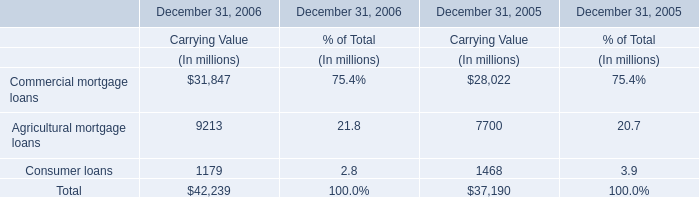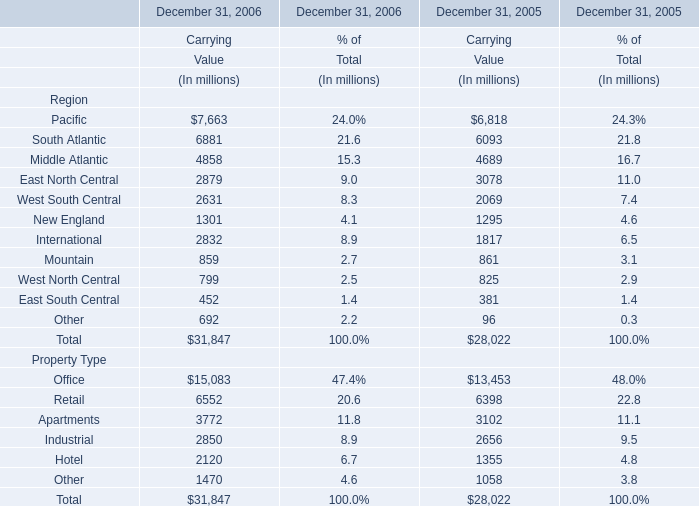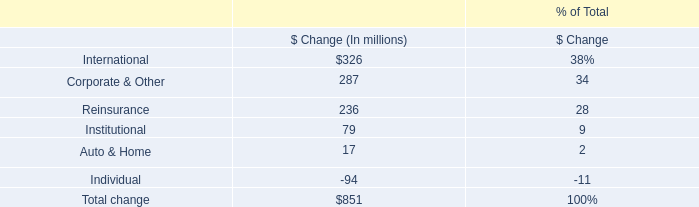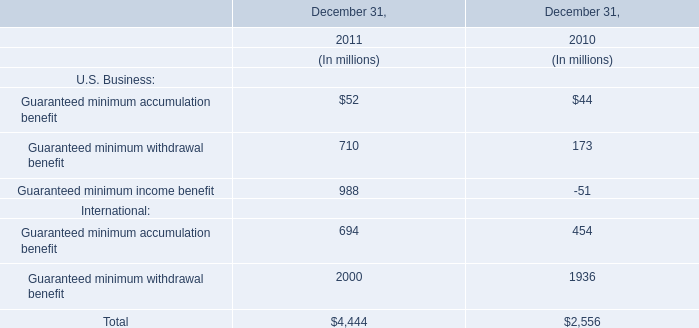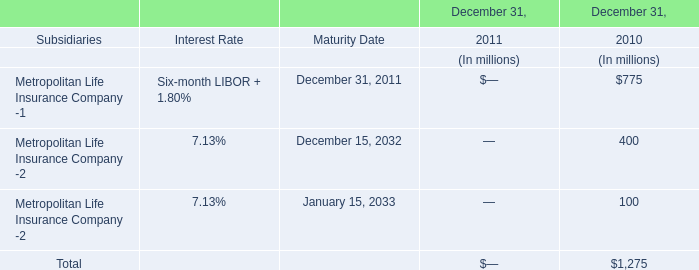What is the proportion of all Region that are greater than 5000 to the total amount of Region, in 2006? 
Computations: (((((7663 + 6881) + 31847) + 15083) + 6552) / 31847)
Answer: 2.13603. 